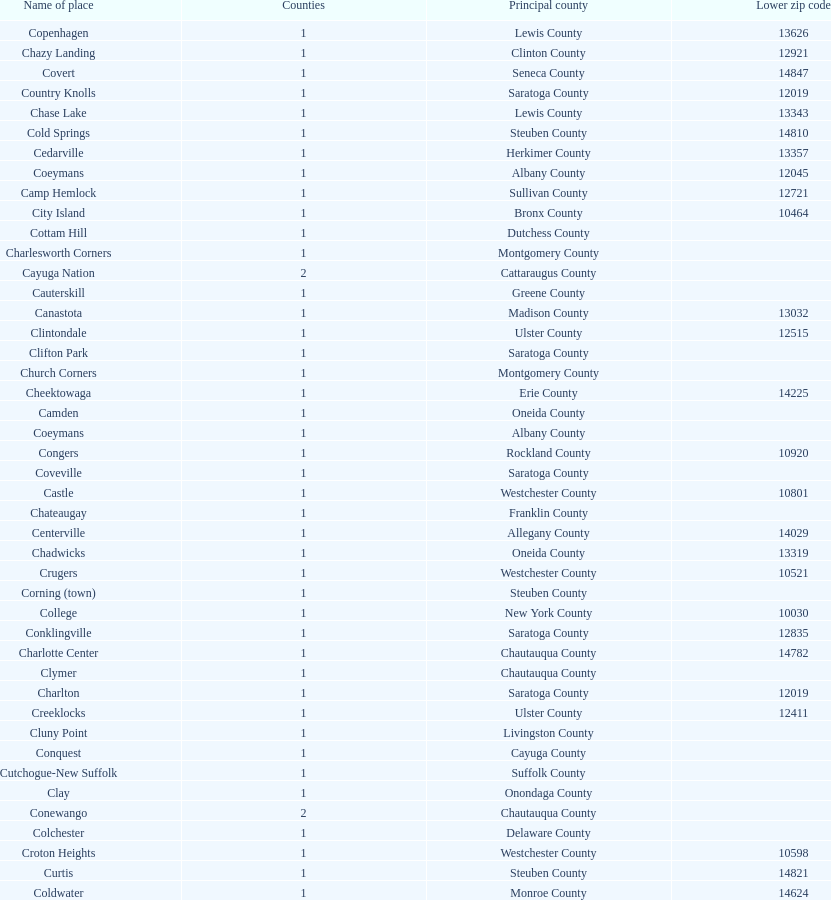How many places are in greene county? 10. 